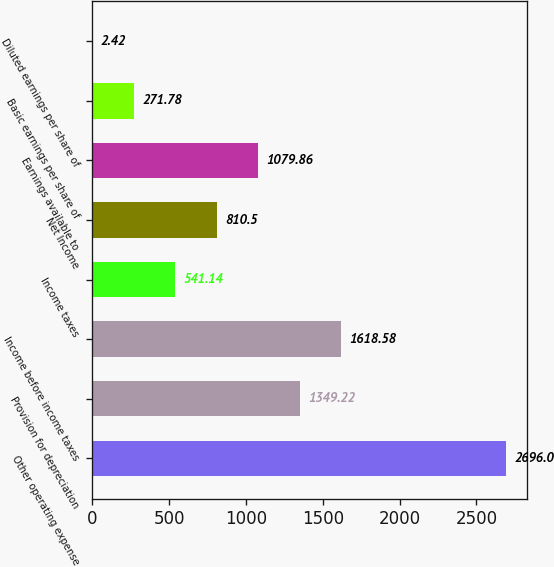Convert chart. <chart><loc_0><loc_0><loc_500><loc_500><bar_chart><fcel>Other operating expense<fcel>Provision for depreciation<fcel>Income before income taxes<fcel>Income taxes<fcel>Net Income<fcel>Earnings available to<fcel>Basic earnings per share of<fcel>Diluted earnings per share of<nl><fcel>2696<fcel>1349.22<fcel>1618.58<fcel>541.14<fcel>810.5<fcel>1079.86<fcel>271.78<fcel>2.42<nl></chart> 